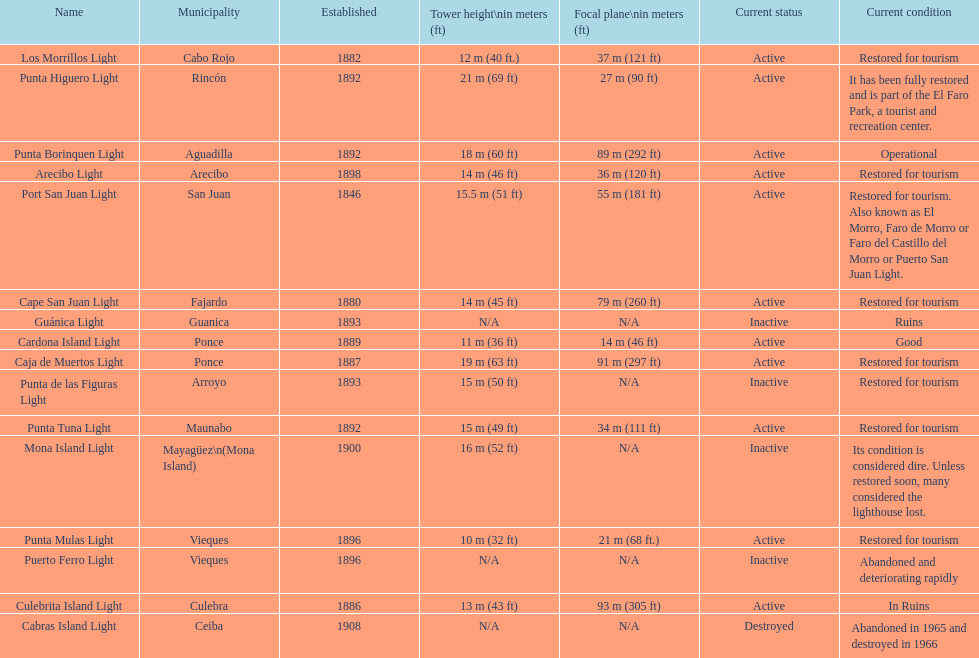Which city was the first to be established? San Juan. 